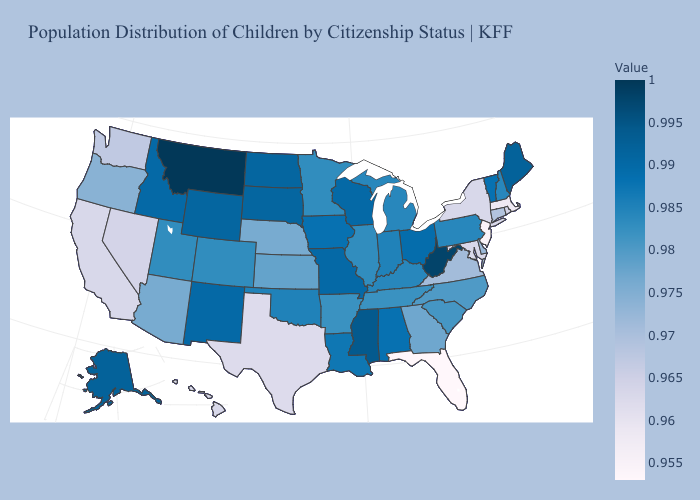Does the map have missing data?
Write a very short answer. No. Does Rhode Island have a lower value than Florida?
Write a very short answer. No. Among the states that border Ohio , which have the lowest value?
Short answer required. Kentucky, Michigan, Pennsylvania. Does Massachusetts have a higher value than Wyoming?
Short answer required. No. 